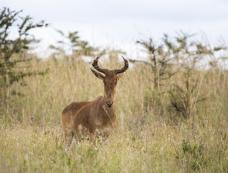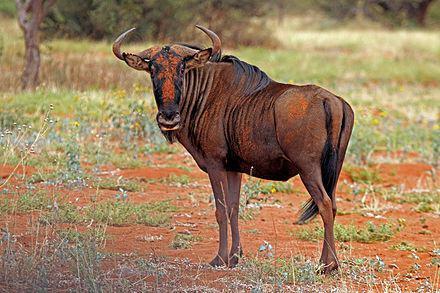The first image is the image on the left, the second image is the image on the right. Considering the images on both sides, is "The left and right image contains the same number of right facing antelopes." valid? Answer yes or no. No. The first image is the image on the left, the second image is the image on the right. Assess this claim about the two images: "One animal is heading left with their head turned and looking into the camera.". Correct or not? Answer yes or no. Yes. 